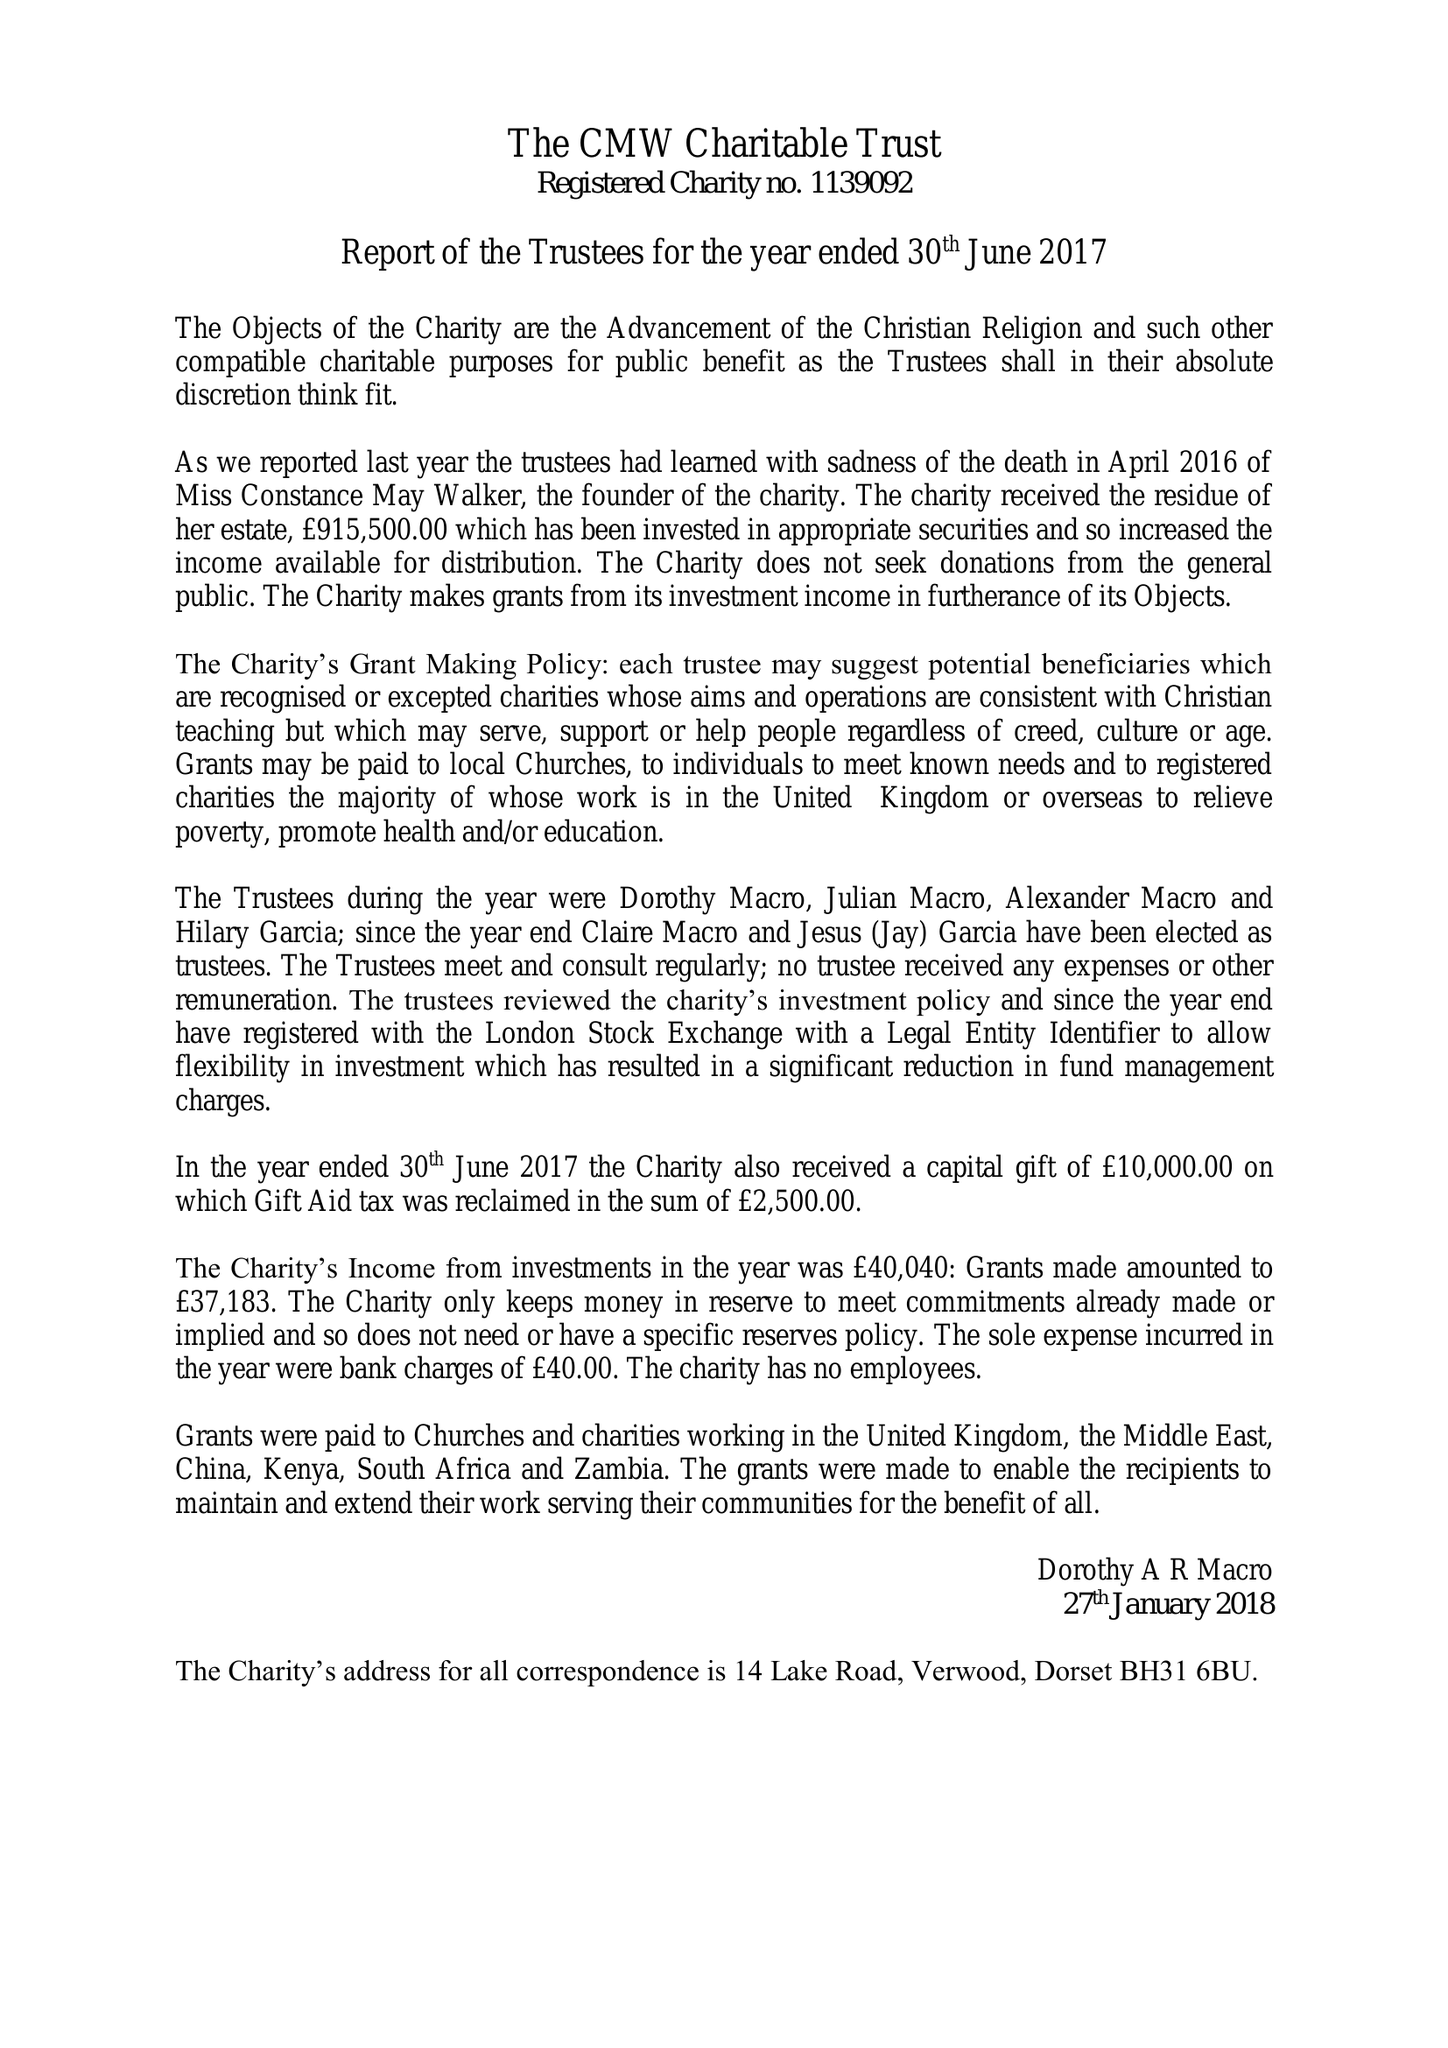What is the value for the address__post_town?
Answer the question using a single word or phrase. VERWOOD 